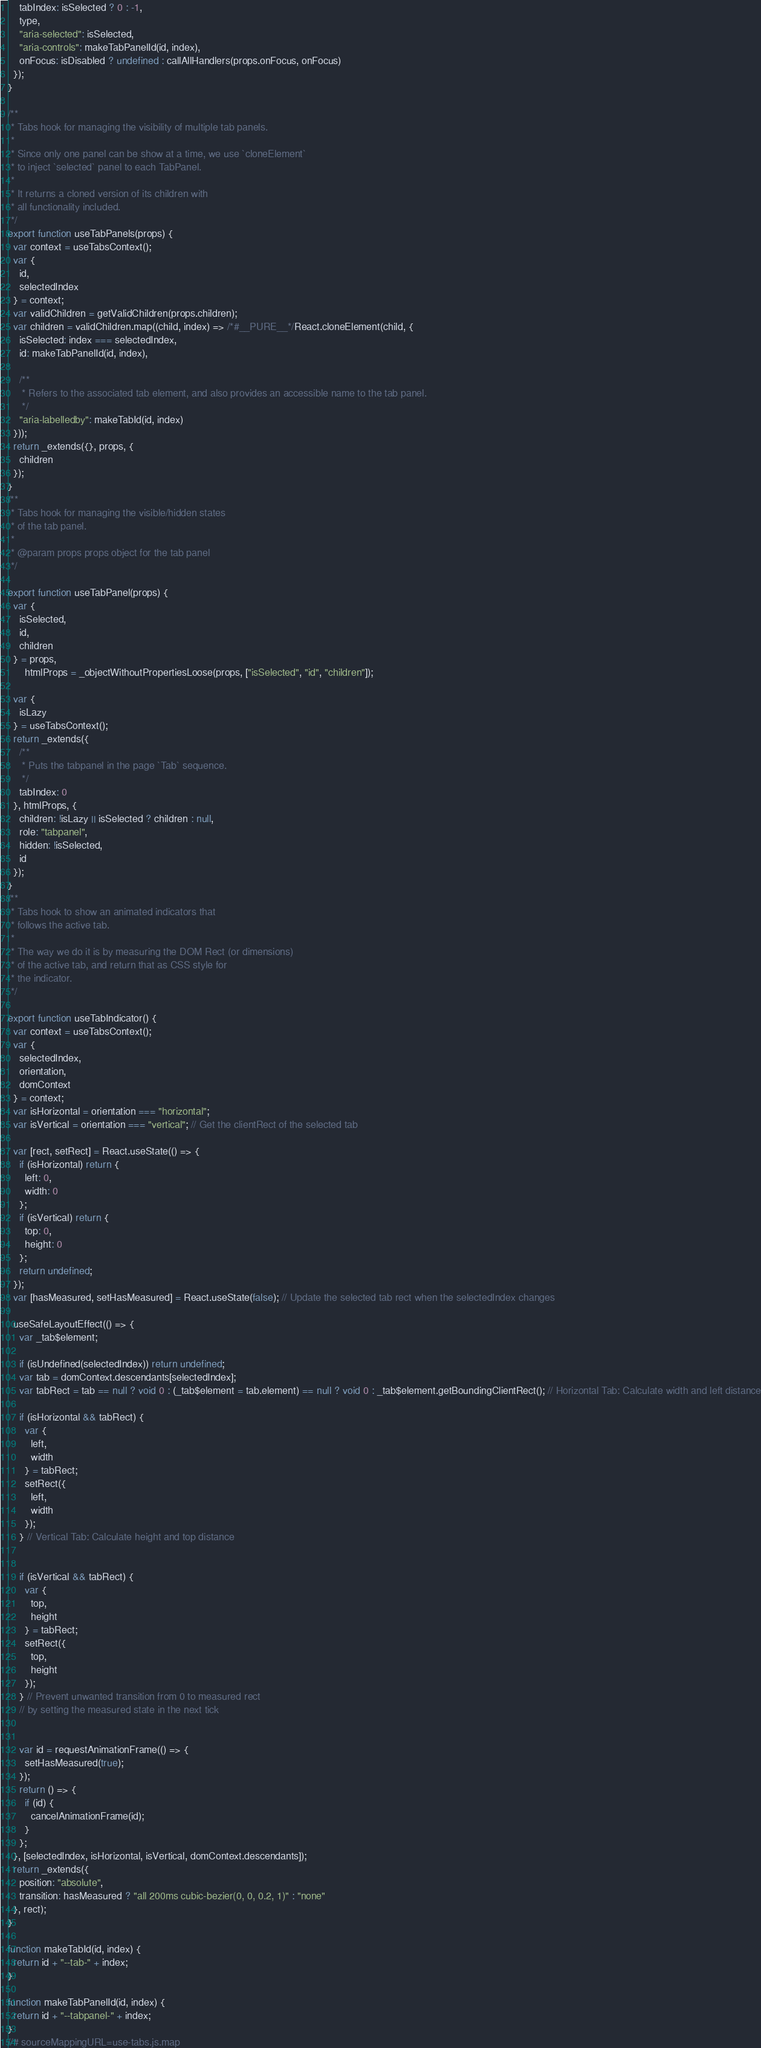Convert code to text. <code><loc_0><loc_0><loc_500><loc_500><_JavaScript_>    tabIndex: isSelected ? 0 : -1,
    type,
    "aria-selected": isSelected,
    "aria-controls": makeTabPanelId(id, index),
    onFocus: isDisabled ? undefined : callAllHandlers(props.onFocus, onFocus)
  });
}

/**
 * Tabs hook for managing the visibility of multiple tab panels.
 *
 * Since only one panel can be show at a time, we use `cloneElement`
 * to inject `selected` panel to each TabPanel.
 *
 * It returns a cloned version of its children with
 * all functionality included.
 */
export function useTabPanels(props) {
  var context = useTabsContext();
  var {
    id,
    selectedIndex
  } = context;
  var validChildren = getValidChildren(props.children);
  var children = validChildren.map((child, index) => /*#__PURE__*/React.cloneElement(child, {
    isSelected: index === selectedIndex,
    id: makeTabPanelId(id, index),

    /**
     * Refers to the associated tab element, and also provides an accessible name to the tab panel.
     */
    "aria-labelledby": makeTabId(id, index)
  }));
  return _extends({}, props, {
    children
  });
}
/**
 * Tabs hook for managing the visible/hidden states
 * of the tab panel.
 *
 * @param props props object for the tab panel
 */

export function useTabPanel(props) {
  var {
    isSelected,
    id,
    children
  } = props,
      htmlProps = _objectWithoutPropertiesLoose(props, ["isSelected", "id", "children"]);

  var {
    isLazy
  } = useTabsContext();
  return _extends({
    /**
     * Puts the tabpanel in the page `Tab` sequence.
     */
    tabIndex: 0
  }, htmlProps, {
    children: !isLazy || isSelected ? children : null,
    role: "tabpanel",
    hidden: !isSelected,
    id
  });
}
/**
 * Tabs hook to show an animated indicators that
 * follows the active tab.
 *
 * The way we do it is by measuring the DOM Rect (or dimensions)
 * of the active tab, and return that as CSS style for
 * the indicator.
 */

export function useTabIndicator() {
  var context = useTabsContext();
  var {
    selectedIndex,
    orientation,
    domContext
  } = context;
  var isHorizontal = orientation === "horizontal";
  var isVertical = orientation === "vertical"; // Get the clientRect of the selected tab

  var [rect, setRect] = React.useState(() => {
    if (isHorizontal) return {
      left: 0,
      width: 0
    };
    if (isVertical) return {
      top: 0,
      height: 0
    };
    return undefined;
  });
  var [hasMeasured, setHasMeasured] = React.useState(false); // Update the selected tab rect when the selectedIndex changes

  useSafeLayoutEffect(() => {
    var _tab$element;

    if (isUndefined(selectedIndex)) return undefined;
    var tab = domContext.descendants[selectedIndex];
    var tabRect = tab == null ? void 0 : (_tab$element = tab.element) == null ? void 0 : _tab$element.getBoundingClientRect(); // Horizontal Tab: Calculate width and left distance

    if (isHorizontal && tabRect) {
      var {
        left,
        width
      } = tabRect;
      setRect({
        left,
        width
      });
    } // Vertical Tab: Calculate height and top distance


    if (isVertical && tabRect) {
      var {
        top,
        height
      } = tabRect;
      setRect({
        top,
        height
      });
    } // Prevent unwanted transition from 0 to measured rect
    // by setting the measured state in the next tick


    var id = requestAnimationFrame(() => {
      setHasMeasured(true);
    });
    return () => {
      if (id) {
        cancelAnimationFrame(id);
      }
    };
  }, [selectedIndex, isHorizontal, isVertical, domContext.descendants]);
  return _extends({
    position: "absolute",
    transition: hasMeasured ? "all 200ms cubic-bezier(0, 0, 0.2, 1)" : "none"
  }, rect);
}

function makeTabId(id, index) {
  return id + "--tab-" + index;
}

function makeTabPanelId(id, index) {
  return id + "--tabpanel-" + index;
}
//# sourceMappingURL=use-tabs.js.map</code> 